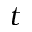Convert formula to latex. <formula><loc_0><loc_0><loc_500><loc_500>t</formula> 